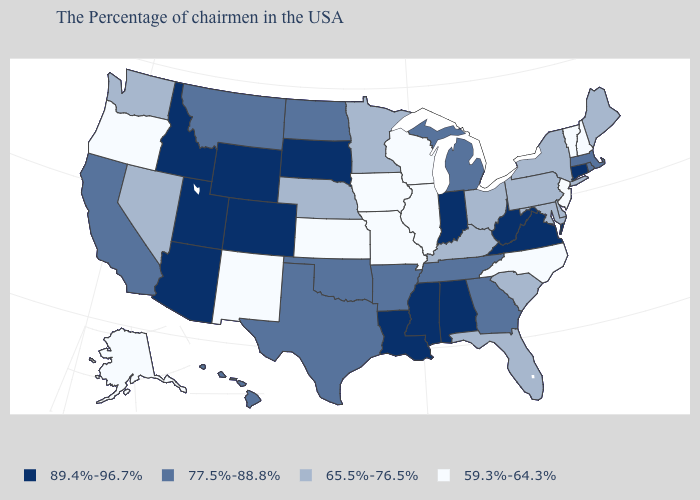Name the states that have a value in the range 59.3%-64.3%?
Be succinct. New Hampshire, Vermont, New Jersey, North Carolina, Wisconsin, Illinois, Missouri, Iowa, Kansas, New Mexico, Oregon, Alaska. What is the value of New Mexico?
Concise answer only. 59.3%-64.3%. What is the value of Virginia?
Concise answer only. 89.4%-96.7%. Among the states that border Washington , which have the lowest value?
Short answer required. Oregon. Name the states that have a value in the range 65.5%-76.5%?
Write a very short answer. Maine, New York, Delaware, Maryland, Pennsylvania, South Carolina, Ohio, Florida, Kentucky, Minnesota, Nebraska, Nevada, Washington. What is the highest value in the MidWest ?
Quick response, please. 89.4%-96.7%. Among the states that border Texas , which have the highest value?
Give a very brief answer. Louisiana. What is the value of Idaho?
Keep it brief. 89.4%-96.7%. Is the legend a continuous bar?
Keep it brief. No. Among the states that border Wisconsin , which have the lowest value?
Give a very brief answer. Illinois, Iowa. What is the value of Florida?
Be succinct. 65.5%-76.5%. Does Arkansas have the same value as Tennessee?
Short answer required. Yes. What is the lowest value in the South?
Concise answer only. 59.3%-64.3%. What is the value of Ohio?
Be succinct. 65.5%-76.5%. Does Alaska have the highest value in the West?
Write a very short answer. No. 